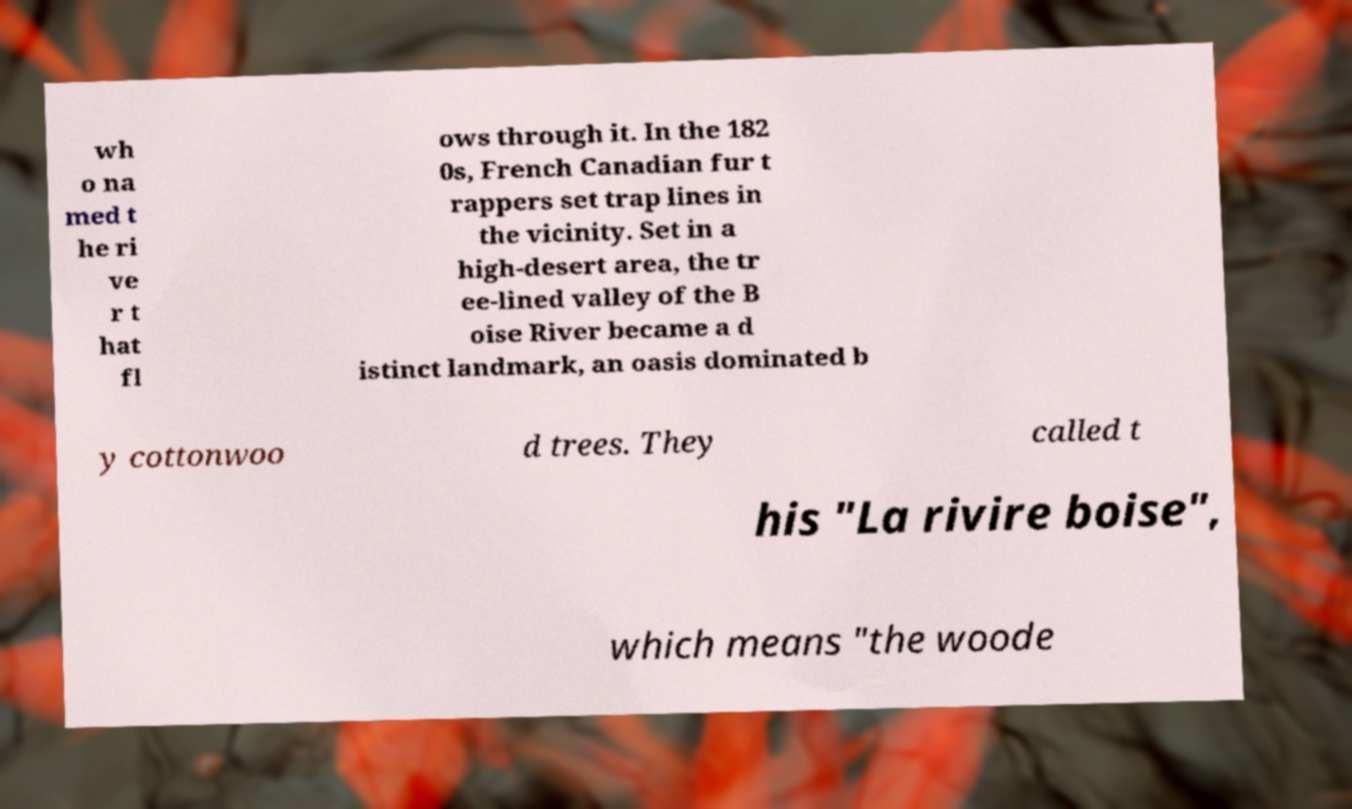I need the written content from this picture converted into text. Can you do that? wh o na med t he ri ve r t hat fl ows through it. In the 182 0s, French Canadian fur t rappers set trap lines in the vicinity. Set in a high-desert area, the tr ee-lined valley of the B oise River became a d istinct landmark, an oasis dominated b y cottonwoo d trees. They called t his "La rivire boise", which means "the woode 